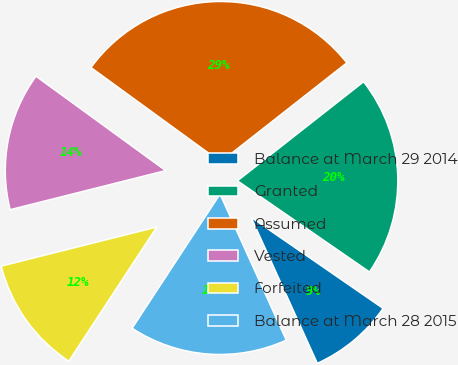Convert chart. <chart><loc_0><loc_0><loc_500><loc_500><pie_chart><fcel>Balance at March 29 2014<fcel>Granted<fcel>Assumed<fcel>Vested<fcel>Forfeited<fcel>Balance at March 28 2015<nl><fcel>8.61%<fcel>20.21%<fcel>29.4%<fcel>13.93%<fcel>11.85%<fcel>16.01%<nl></chart> 